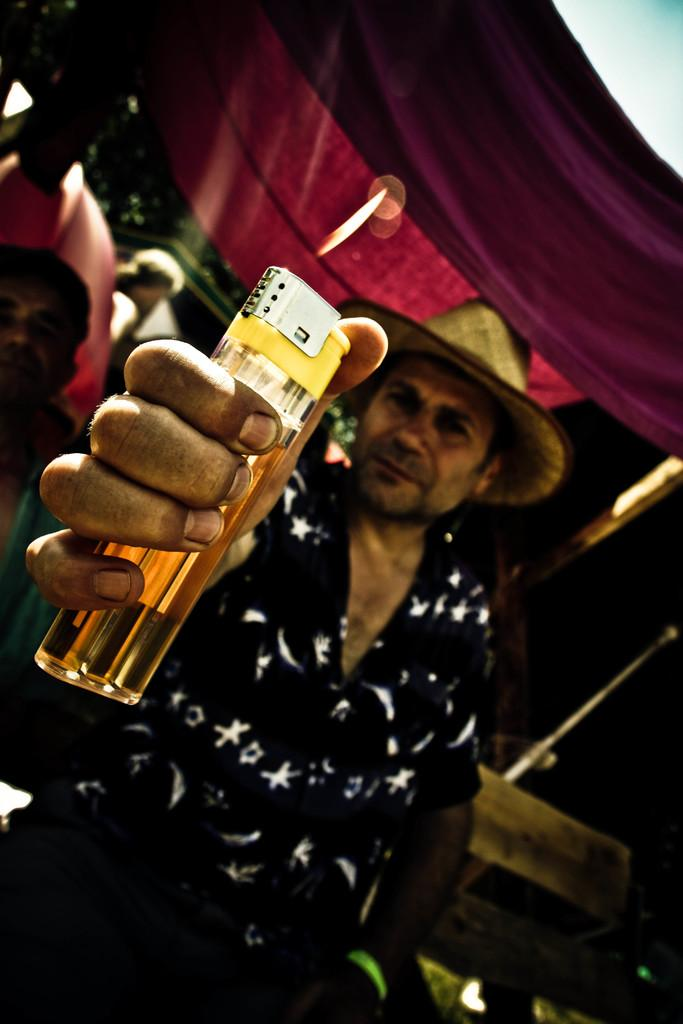Who or what is the main subject in the image? There is a person in the image. What is the person holding in his hand? The person is holding a lighter in his hand. What type of clothing is the person wearing on his head? The person is wearing a hat on his head. Can you describe the scene in the background of the image? There are people visible in the background of the image. What type of turkey can be seen flying in the image? There is no turkey present in the image. What kind of cloud formation is visible in the image? The image does not show any clouds; it is focused on the person and the background. 